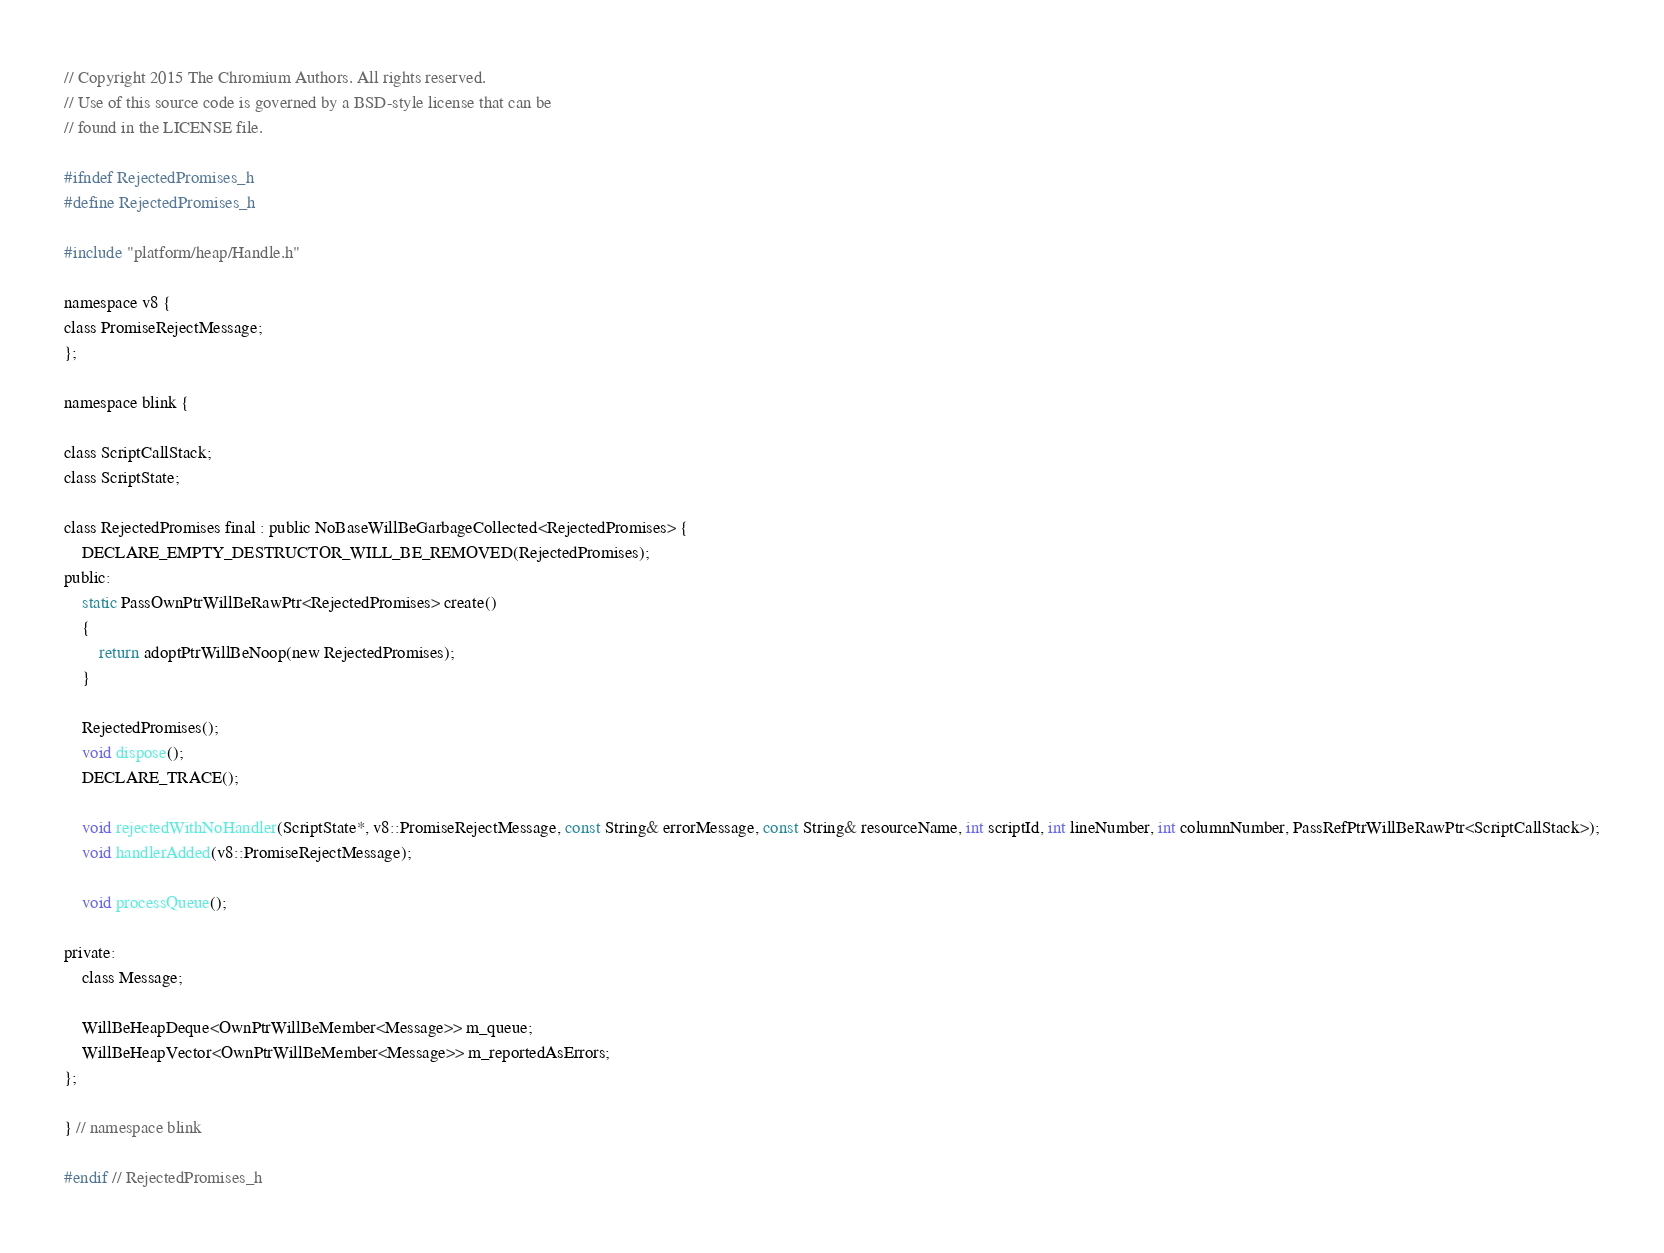Convert code to text. <code><loc_0><loc_0><loc_500><loc_500><_C_>// Copyright 2015 The Chromium Authors. All rights reserved.
// Use of this source code is governed by a BSD-style license that can be
// found in the LICENSE file.

#ifndef RejectedPromises_h
#define RejectedPromises_h

#include "platform/heap/Handle.h"

namespace v8 {
class PromiseRejectMessage;
};

namespace blink {

class ScriptCallStack;
class ScriptState;

class RejectedPromises final : public NoBaseWillBeGarbageCollected<RejectedPromises> {
    DECLARE_EMPTY_DESTRUCTOR_WILL_BE_REMOVED(RejectedPromises);
public:
    static PassOwnPtrWillBeRawPtr<RejectedPromises> create()
    {
        return adoptPtrWillBeNoop(new RejectedPromises);
    }

    RejectedPromises();
    void dispose();
    DECLARE_TRACE();

    void rejectedWithNoHandler(ScriptState*, v8::PromiseRejectMessage, const String& errorMessage, const String& resourceName, int scriptId, int lineNumber, int columnNumber, PassRefPtrWillBeRawPtr<ScriptCallStack>);
    void handlerAdded(v8::PromiseRejectMessage);

    void processQueue();

private:
    class Message;

    WillBeHeapDeque<OwnPtrWillBeMember<Message>> m_queue;
    WillBeHeapVector<OwnPtrWillBeMember<Message>> m_reportedAsErrors;
};

} // namespace blink

#endif // RejectedPromises_h
</code> 